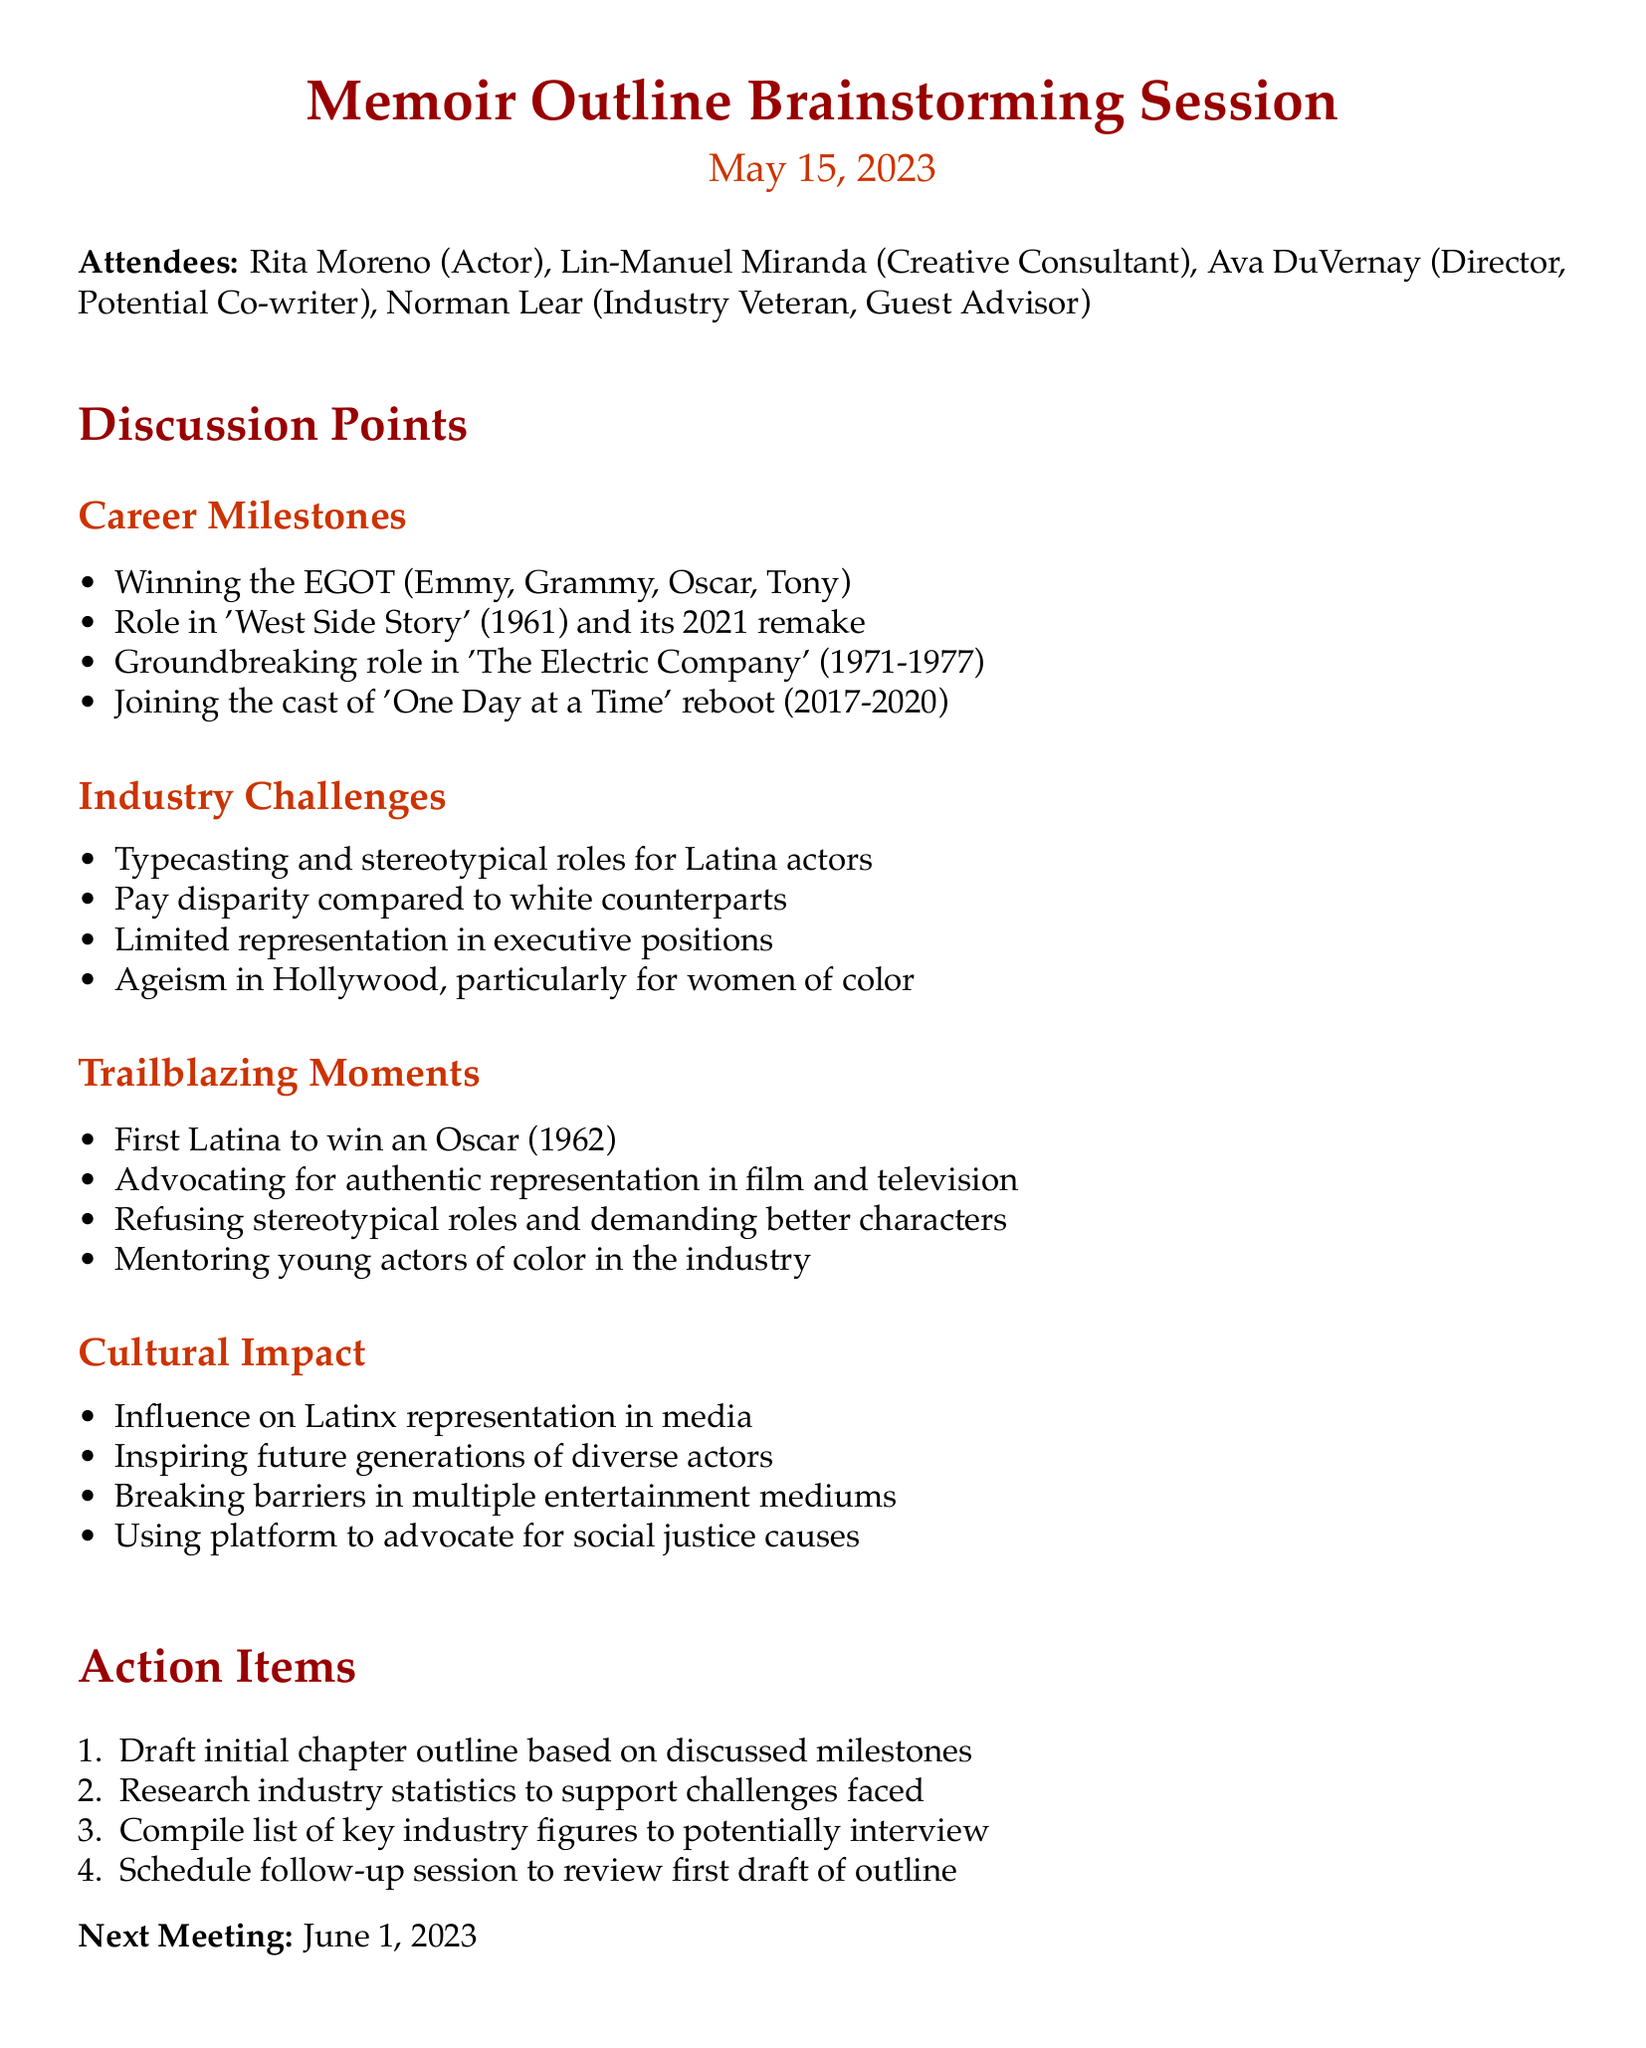What is the date of the meeting? The date of the meeting is explicitly mentioned in the document as May 15, 2023.
Answer: May 15, 2023 Who is a guest advisor at the meeting? The document lists Norman Lear as a Guest Advisor among the attendees.
Answer: Norman Lear What was a groundbreaking role for Rita Moreno mentioned in the discussion? The document highlights Rita Moreno's role in 'The Electric Company' (1971-1977) as a significant milestone in her career.
Answer: The Electric Company What is one of the industry challenges faced by Latina actors? The document discusses pay disparity compared to white counterparts as one of the challenges observed in the industry.
Answer: Pay disparity Which cultural impact is highlighted in relation to Rita Moreno's work? The document states that her influence on Latinx representation in media is a significant cultural impact she has had through her work.
Answer: Influence on Latinx representation What is one action item from the meeting? The document mentions drafting an initial chapter outline based on the discussed milestones as one of the action items.
Answer: Draft initial chapter outline How many people attended the meeting? The document lists four attendees who were present at the meeting, indicating the size of the group.
Answer: Four When is the next meeting scheduled? The next meeting date is specified clearly in the document as June 1, 2023.
Answer: June 1, 2023 